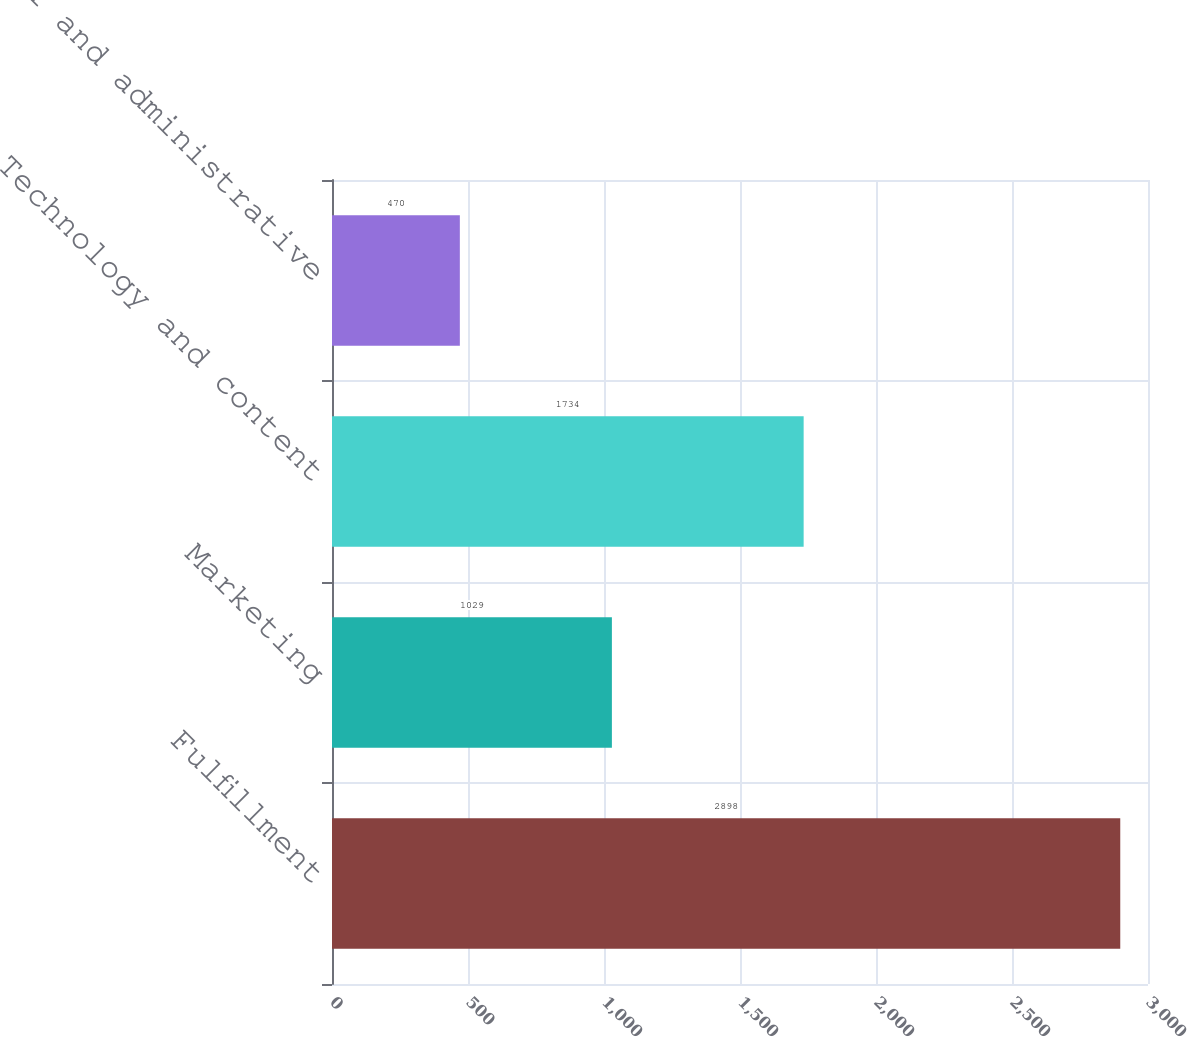Convert chart. <chart><loc_0><loc_0><loc_500><loc_500><bar_chart><fcel>Fulfillment<fcel>Marketing<fcel>Technology and content<fcel>General and administrative<nl><fcel>2898<fcel>1029<fcel>1734<fcel>470<nl></chart> 